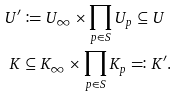Convert formula to latex. <formula><loc_0><loc_0><loc_500><loc_500>U ^ { \prime } & \coloneqq U _ { \infty } \times \prod _ { p \in S } U _ { p } \subseteq U \\ K & \subseteq K _ { \infty } \times \prod _ { p \in S } K _ { p } \eqqcolon K ^ { \prime } .</formula> 